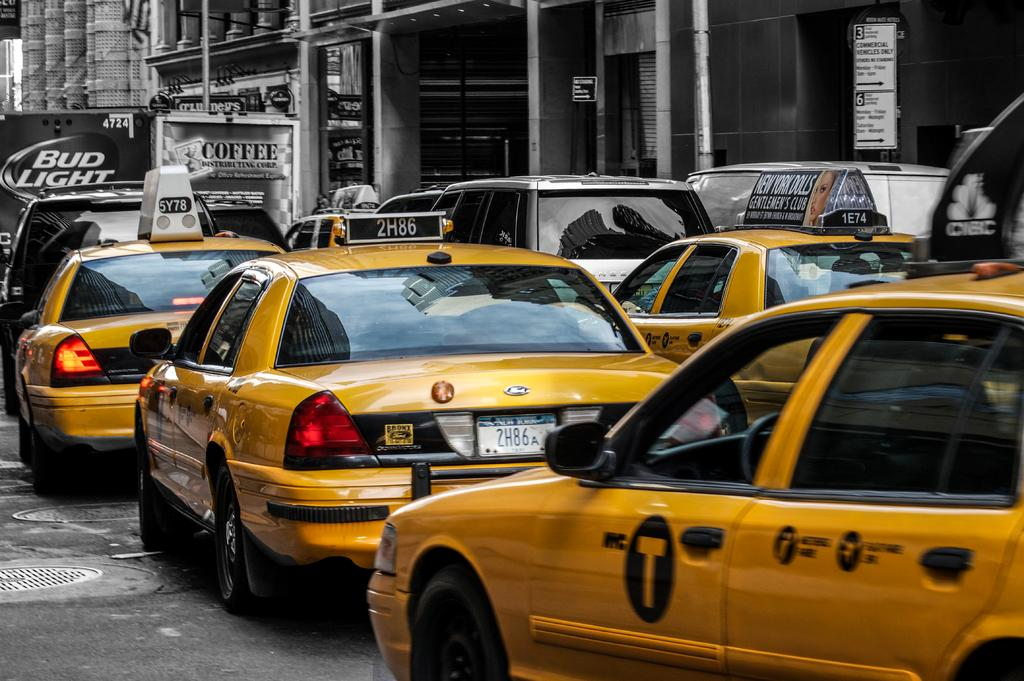<image>
Provide a brief description of the given image. A line of taxi cabs are behind a truck advertising Bud Light. 